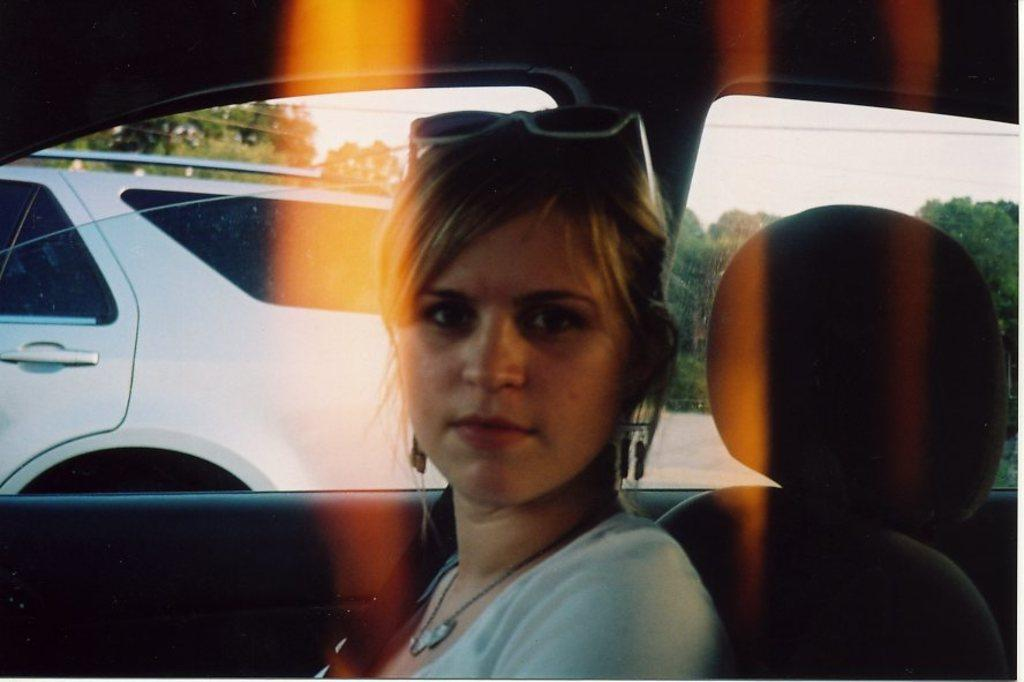What is the woman in the image doing? The woman is sitting in the car. What is the car doing in the image? The car is traveling on the road. What can be seen in the background of the image? Trees and the sky are visible in the image. What type of toothpaste is the woman using in the image? There is no toothpaste present in the image, as the woman is sitting in a car. What is the woman's head doing in the image? The woman's head is not doing anything in the image; it is simply resting on her body while she sits in the car. 